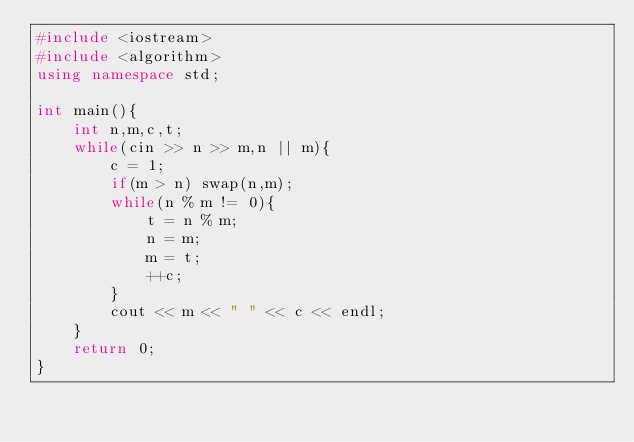Convert code to text. <code><loc_0><loc_0><loc_500><loc_500><_C++_>#include <iostream>
#include <algorithm>
using namespace std;

int main(){
	int n,m,c,t;
	while(cin >> n >> m,n || m){
		c = 1;
		if(m > n) swap(n,m);
		while(n % m != 0){
			t = n % m;
			n = m;
			m = t;
			++c;
		}
		cout << m << " " << c << endl;
	}
	return 0;
}</code> 